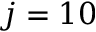<formula> <loc_0><loc_0><loc_500><loc_500>j = 1 0</formula> 